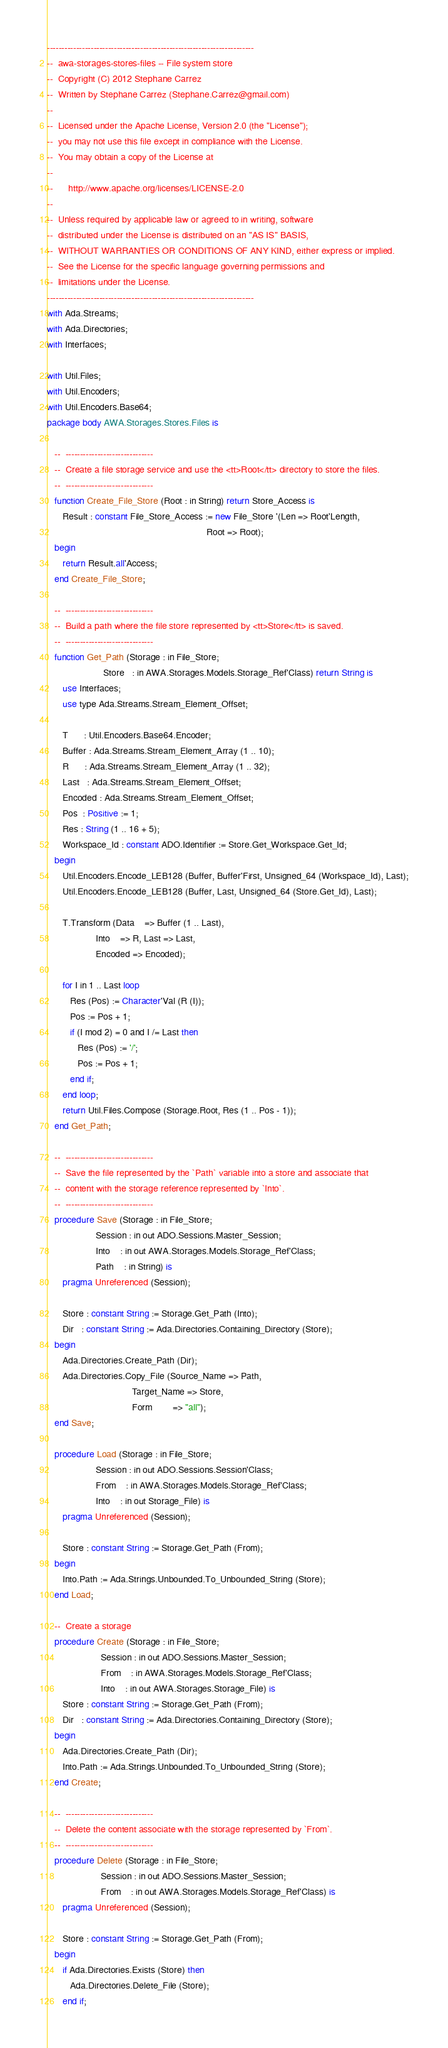<code> <loc_0><loc_0><loc_500><loc_500><_Ada_>-----------------------------------------------------------------------
--  awa-storages-stores-files -- File system store
--  Copyright (C) 2012 Stephane Carrez
--  Written by Stephane Carrez (Stephane.Carrez@gmail.com)
--
--  Licensed under the Apache License, Version 2.0 (the "License");
--  you may not use this file except in compliance with the License.
--  You may obtain a copy of the License at
--
--      http://www.apache.org/licenses/LICENSE-2.0
--
--  Unless required by applicable law or agreed to in writing, software
--  distributed under the License is distributed on an "AS IS" BASIS,
--  WITHOUT WARRANTIES OR CONDITIONS OF ANY KIND, either express or implied.
--  See the License for the specific language governing permissions and
--  limitations under the License.
-----------------------------------------------------------------------
with Ada.Streams;
with Ada.Directories;
with Interfaces;

with Util.Files;
with Util.Encoders;
with Util.Encoders.Base64;
package body AWA.Storages.Stores.Files is

   --  ------------------------------
   --  Create a file storage service and use the <tt>Root</tt> directory to store the files.
   --  ------------------------------
   function Create_File_Store (Root : in String) return Store_Access is
      Result : constant File_Store_Access := new File_Store '(Len => Root'Length,
                                                              Root => Root);
   begin
      return Result.all'Access;
   end Create_File_Store;

   --  ------------------------------
   --  Build a path where the file store represented by <tt>Store</tt> is saved.
   --  ------------------------------
   function Get_Path (Storage : in File_Store;
                      Store   : in AWA.Storages.Models.Storage_Ref'Class) return String is
      use Interfaces;
      use type Ada.Streams.Stream_Element_Offset;

      T      : Util.Encoders.Base64.Encoder;
      Buffer : Ada.Streams.Stream_Element_Array (1 .. 10);
      R      : Ada.Streams.Stream_Element_Array (1 .. 32);
      Last   : Ada.Streams.Stream_Element_Offset;
      Encoded : Ada.Streams.Stream_Element_Offset;
      Pos  : Positive := 1;
      Res : String (1 .. 16 + 5);
      Workspace_Id : constant ADO.Identifier := Store.Get_Workspace.Get_Id;
   begin
      Util.Encoders.Encode_LEB128 (Buffer, Buffer'First, Unsigned_64 (Workspace_Id), Last);
      Util.Encoders.Encode_LEB128 (Buffer, Last, Unsigned_64 (Store.Get_Id), Last);

      T.Transform (Data    => Buffer (1 .. Last),
                   Into    => R, Last => Last,
                   Encoded => Encoded);

      for I in 1 .. Last loop
         Res (Pos) := Character'Val (R (I));
         Pos := Pos + 1;
         if (I mod 2) = 0 and I /= Last then
            Res (Pos) := '/';
            Pos := Pos + 1;
         end if;
      end loop;
      return Util.Files.Compose (Storage.Root, Res (1 .. Pos - 1));
   end Get_Path;

   --  ------------------------------
   --  Save the file represented by the `Path` variable into a store and associate that
   --  content with the storage reference represented by `Into`.
   --  ------------------------------
   procedure Save (Storage : in File_Store;
                   Session : in out ADO.Sessions.Master_Session;
                   Into    : in out AWA.Storages.Models.Storage_Ref'Class;
                   Path    : in String) is
      pragma Unreferenced (Session);

      Store : constant String := Storage.Get_Path (Into);
      Dir   : constant String := Ada.Directories.Containing_Directory (Store);
   begin
      Ada.Directories.Create_Path (Dir);
      Ada.Directories.Copy_File (Source_Name => Path,
                                 Target_Name => Store,
                                 Form        => "all");
   end Save;

   procedure Load (Storage : in File_Store;
                   Session : in out ADO.Sessions.Session'Class;
                   From    : in AWA.Storages.Models.Storage_Ref'Class;
                   Into    : in out Storage_File) is
      pragma Unreferenced (Session);

      Store : constant String := Storage.Get_Path (From);
   begin
      Into.Path := Ada.Strings.Unbounded.To_Unbounded_String (Store);
   end Load;

   --  Create a storage
   procedure Create (Storage : in File_Store;
                     Session : in out ADO.Sessions.Master_Session;
                     From    : in AWA.Storages.Models.Storage_Ref'Class;
                     Into    : in out AWA.Storages.Storage_File) is
      Store : constant String := Storage.Get_Path (From);
      Dir   : constant String := Ada.Directories.Containing_Directory (Store);
   begin
      Ada.Directories.Create_Path (Dir);
      Into.Path := Ada.Strings.Unbounded.To_Unbounded_String (Store);
   end Create;

   --  ------------------------------
   --  Delete the content associate with the storage represented by `From`.
   --  ------------------------------
   procedure Delete (Storage : in File_Store;
                     Session : in out ADO.Sessions.Master_Session;
                     From    : in out AWA.Storages.Models.Storage_Ref'Class) is
      pragma Unreferenced (Session);

      Store : constant String := Storage.Get_Path (From);
   begin
      if Ada.Directories.Exists (Store) then
         Ada.Directories.Delete_File (Store);
      end if;</code> 